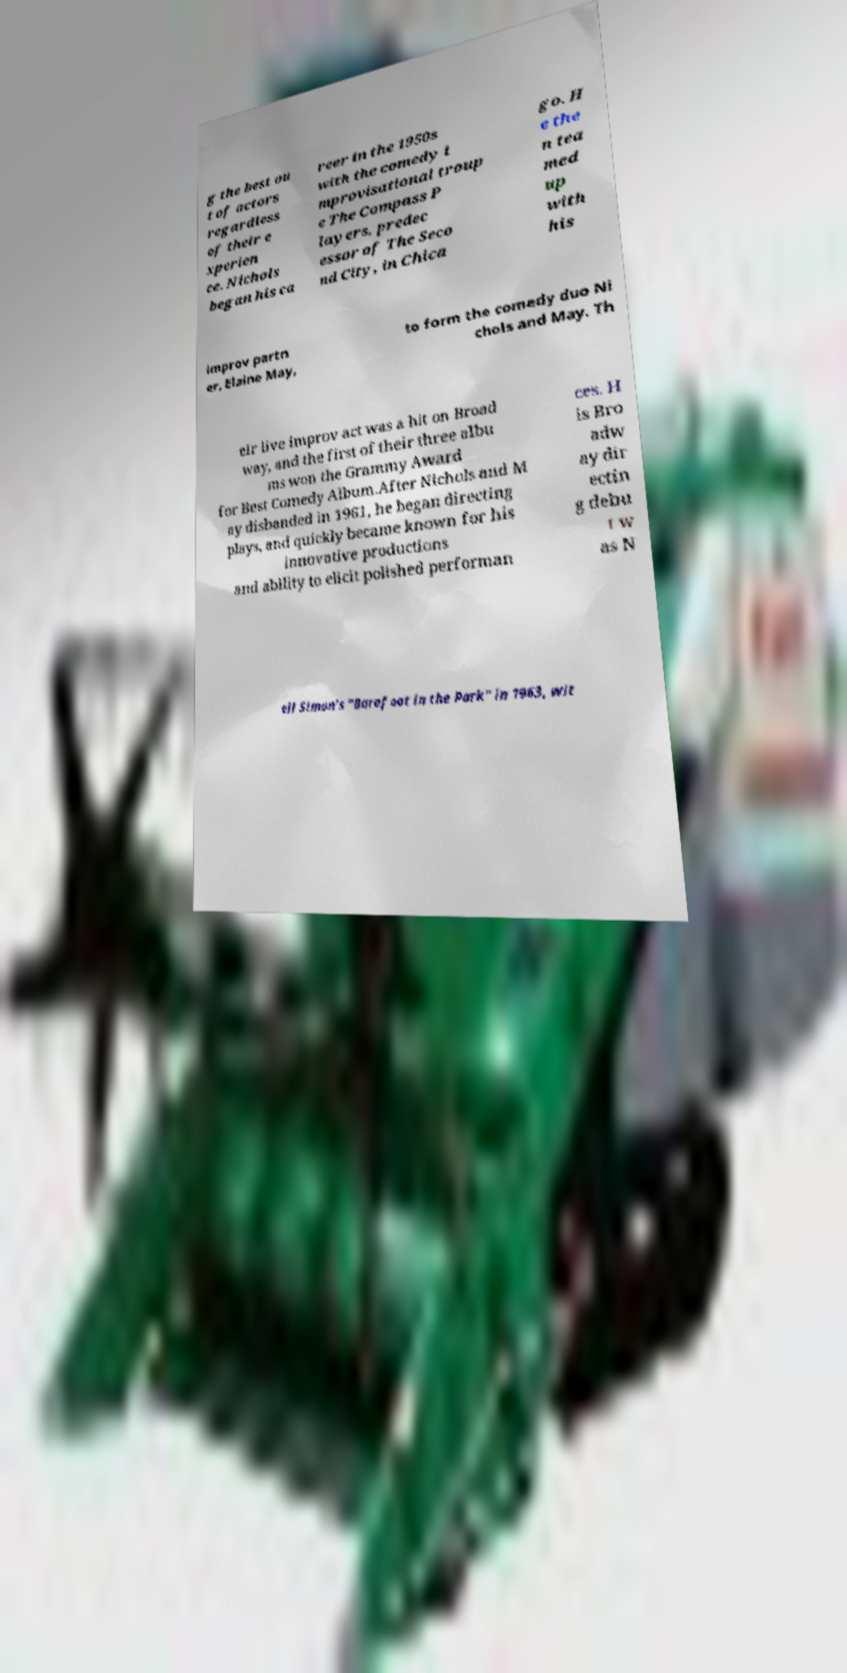I need the written content from this picture converted into text. Can you do that? g the best ou t of actors regardless of their e xperien ce. Nichols began his ca reer in the 1950s with the comedy i mprovisational troup e The Compass P layers, predec essor of The Seco nd City, in Chica go. H e the n tea med up with his improv partn er, Elaine May, to form the comedy duo Ni chols and May. Th eir live improv act was a hit on Broad way, and the first of their three albu ms won the Grammy Award for Best Comedy Album.After Nichols and M ay disbanded in 1961, he began directing plays, and quickly became known for his innovative productions and ability to elicit polished performan ces. H is Bro adw ay dir ectin g debu t w as N eil Simon's "Barefoot in the Park" in 1963, wit 